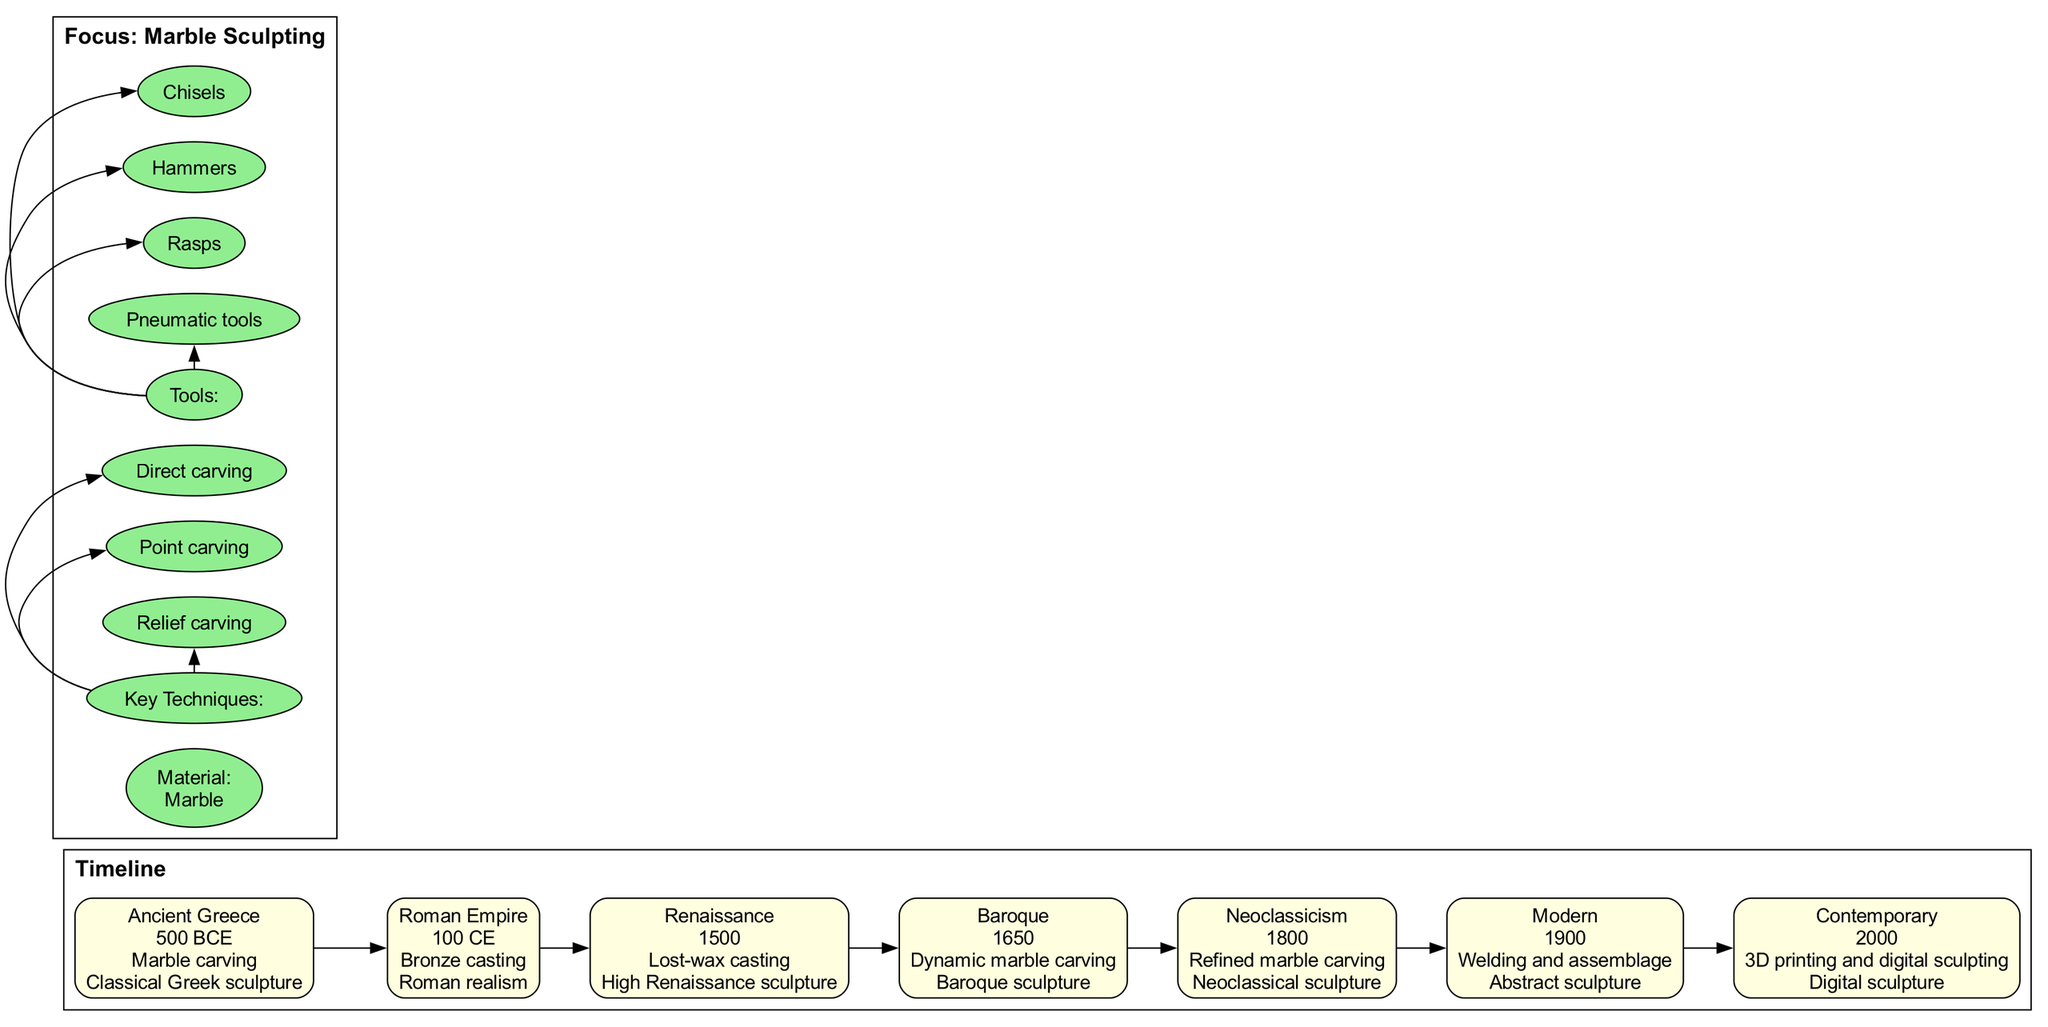What is the primary material used in the focus area of the diagram? The diagram explicitly states the focus material as "Marble" within the focus section labeled "Material."
Answer: Marble How many major sculptural movements are listed in the timeline? The diagram contains seven distinct entries in the timeline, each representing a major sculptural movement throughout various years.
Answer: 7 What technique is highlighted in the Renaissance movement? According to the timeline, the technique associated with the Renaissance movement is "Lost-wax casting," which is noted next to the year 1500.
Answer: Lost-wax casting Which movement utilized dynamic marble carving? The timeline indicates that "Baroque sculpture," which corresponds to the year 1650, employed the technique of dynamic marble carving.
Answer: Baroque sculpture What is the last major sculptural movement mentioned in the timeline? The last entry in the timeline refers to "Digital sculpture" occurring in the year 2000, making it the most recent movement listed.
Answer: Digital sculpture What key technique is employed alongside refined marble carving in Neoclassicism? Neoclassicism incorporates "Refined marble carving," as well as others, but the key one noted immediately is associated with the movement in the timeline.
Answer: Refined marble carving In the focus area, which tool is used for sculpting? The diagram lists several tools in the focus area, and one of them is specified as "Chisels," which is commonly used in sculpture making.
Answer: Chisels Which era corresponds to the introduction of bronze casting? The timeline connects the technique of "Bronze casting" to the "Roman Empire," specifically in the year 100 CE.
Answer: Roman Empire What is the first sculptural movement listed in the timeline? The initial entry of the timeline identifies "Classical Greek sculpture" as the first major movement, which is associated with the year 500 BCE.
Answer: Classical Greek sculpture 